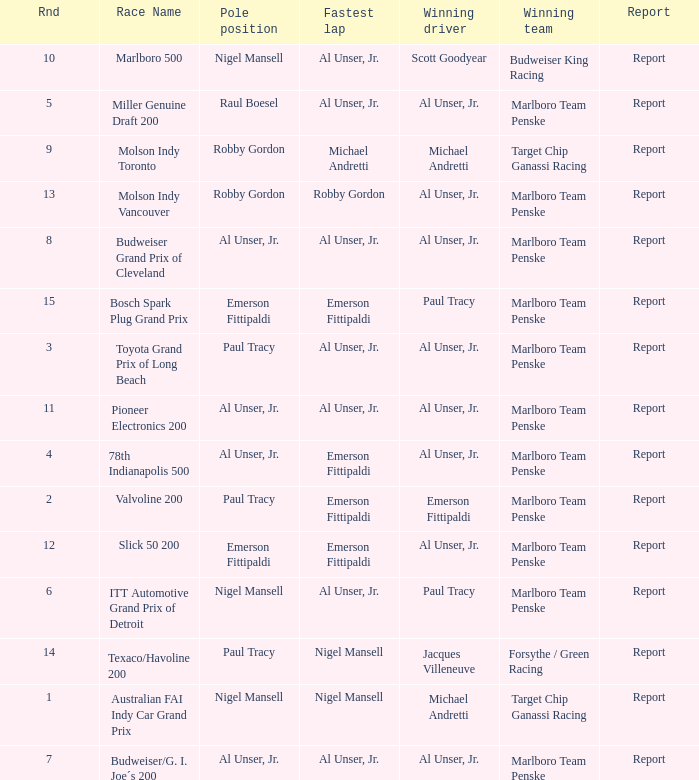Who was on the pole position in the Texaco/Havoline 200 race? Paul Tracy. 